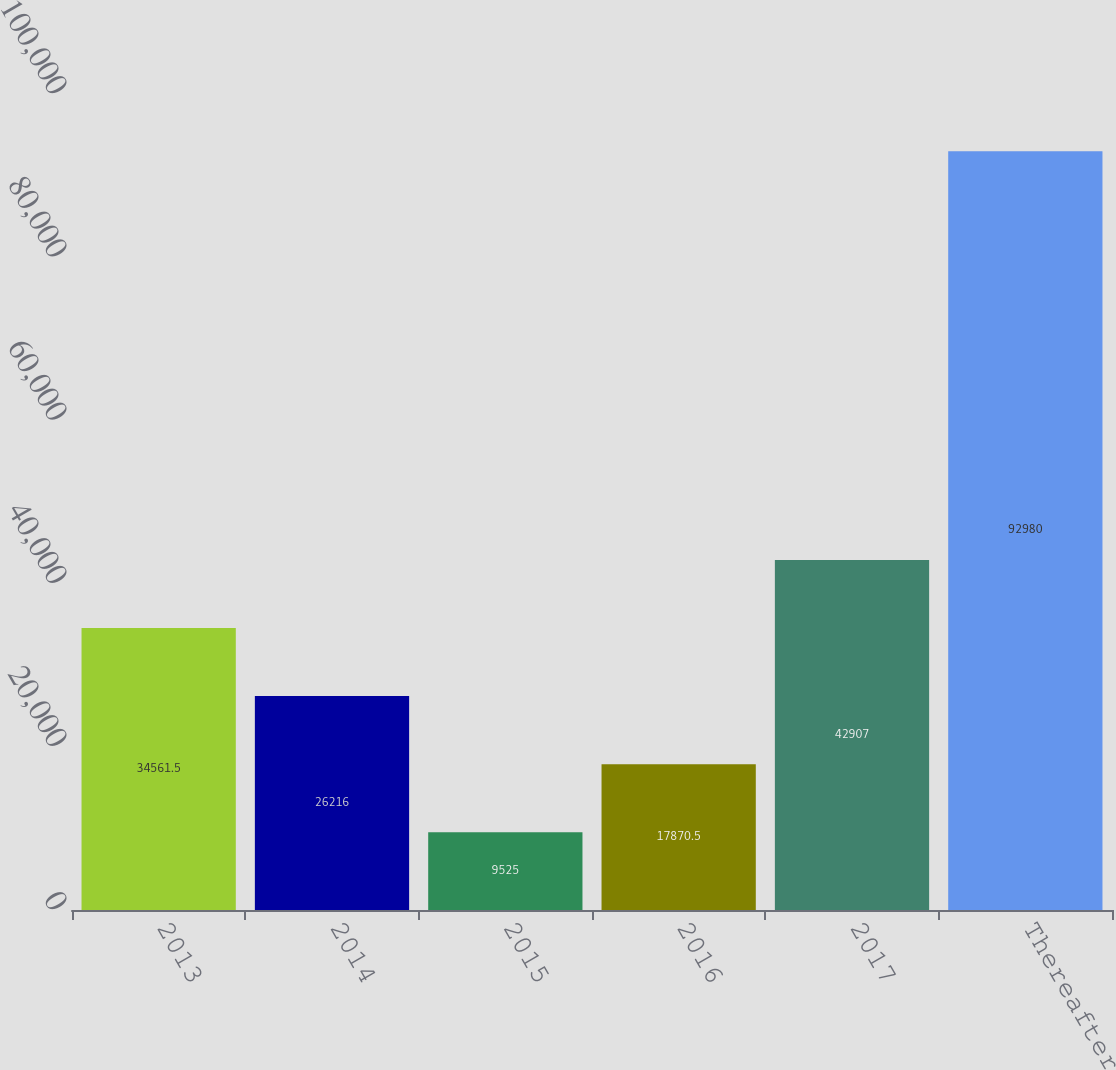Convert chart. <chart><loc_0><loc_0><loc_500><loc_500><bar_chart><fcel>2013<fcel>2014<fcel>2015<fcel>2016<fcel>2017<fcel>Thereafter<nl><fcel>34561.5<fcel>26216<fcel>9525<fcel>17870.5<fcel>42907<fcel>92980<nl></chart> 